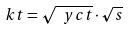<formula> <loc_0><loc_0><loc_500><loc_500>\ k t = \sqrt { \ y c t } \cdot \sqrt { s }</formula> 